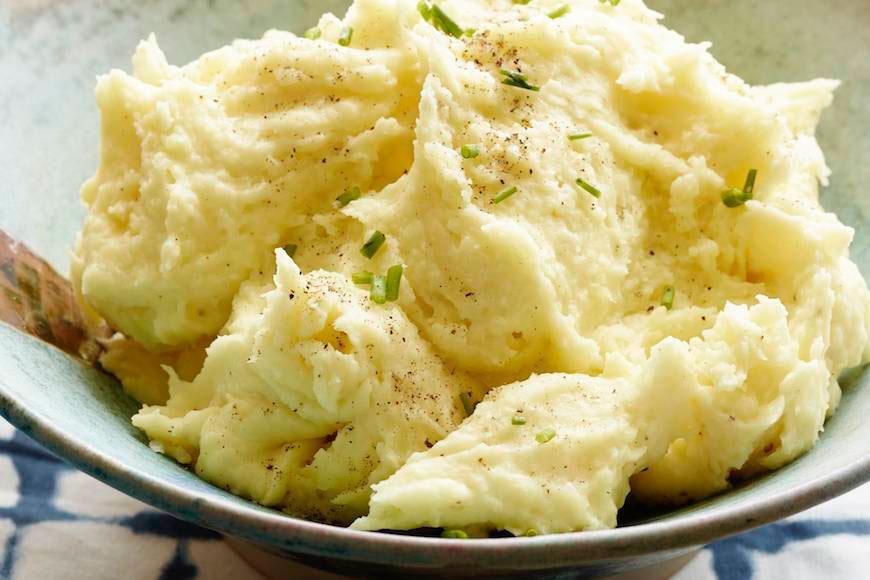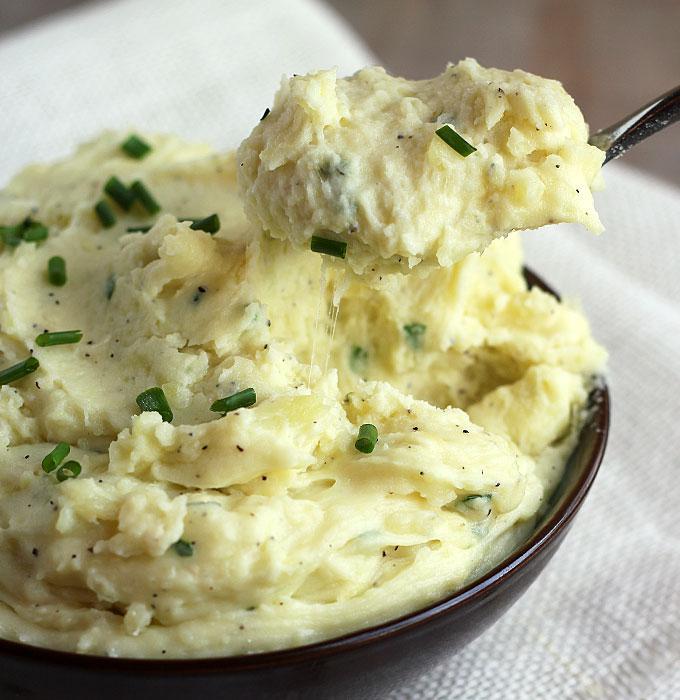The first image is the image on the left, the second image is the image on the right. Analyze the images presented: Is the assertion "The mashed potato bowl on the right contains a serving utensil." valid? Answer yes or no. Yes. 